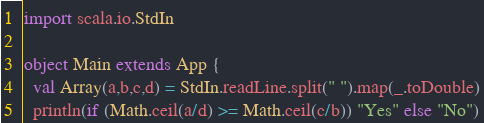Convert code to text. <code><loc_0><loc_0><loc_500><loc_500><_Scala_>import scala.io.StdIn

object Main extends App {
  val Array(a,b,c,d) = StdIn.readLine.split(" ").map(_.toDouble)
  println(if (Math.ceil(a/d) >= Math.ceil(c/b)) "Yes" else "No")
</code> 